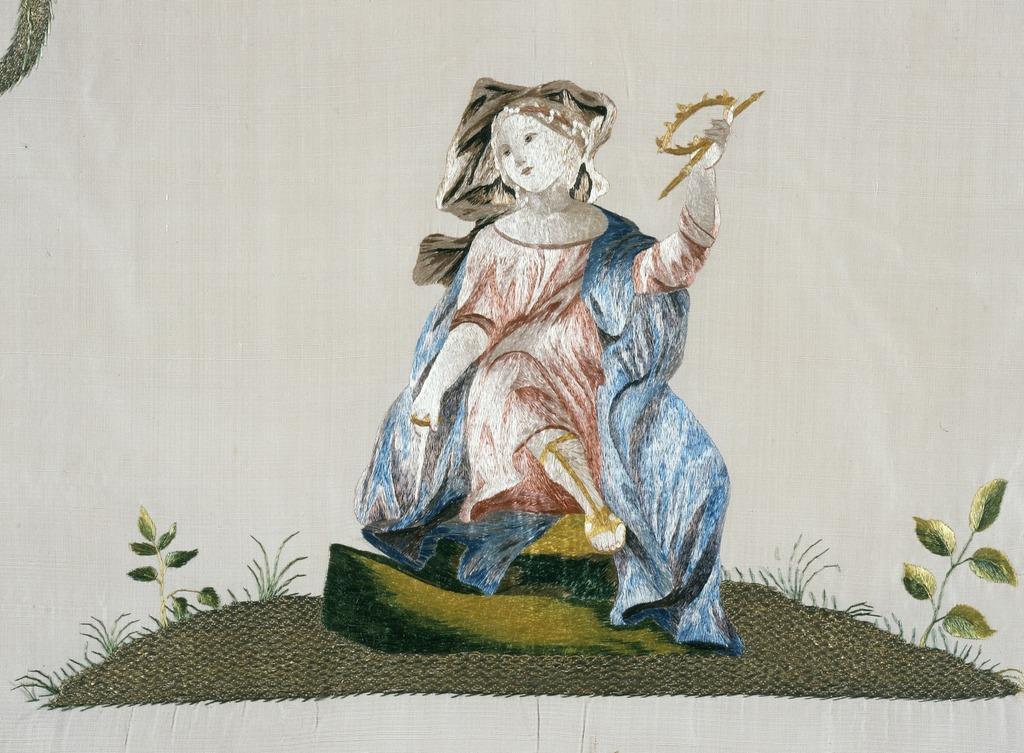Could you give a brief overview of what you see in this image? In this image we can see an art on the white color surface. 